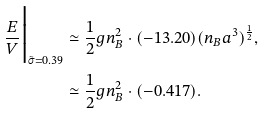Convert formula to latex. <formula><loc_0><loc_0><loc_500><loc_500>\frac { E } { V } \Big | _ { \tilde { \sigma } = 0 . 3 9 } & \simeq \frac { 1 } { 2 } g n _ { B } ^ { 2 } \cdot ( - 1 3 . 2 0 ) ( n _ { B } a ^ { 3 } ) ^ { \frac { 1 } { 2 } } , \\ & \simeq \frac { 1 } { 2 } g n _ { B } ^ { 2 } \cdot ( - 0 . 4 1 7 ) .</formula> 